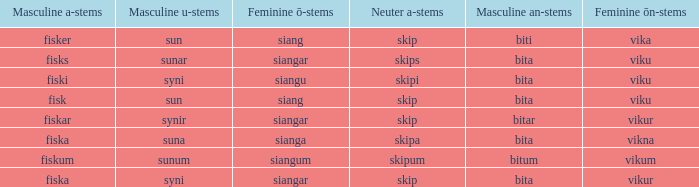What is the an-stem for the expression that has an ö-stems of siangar and an u-stem finish of syni? Bita. 